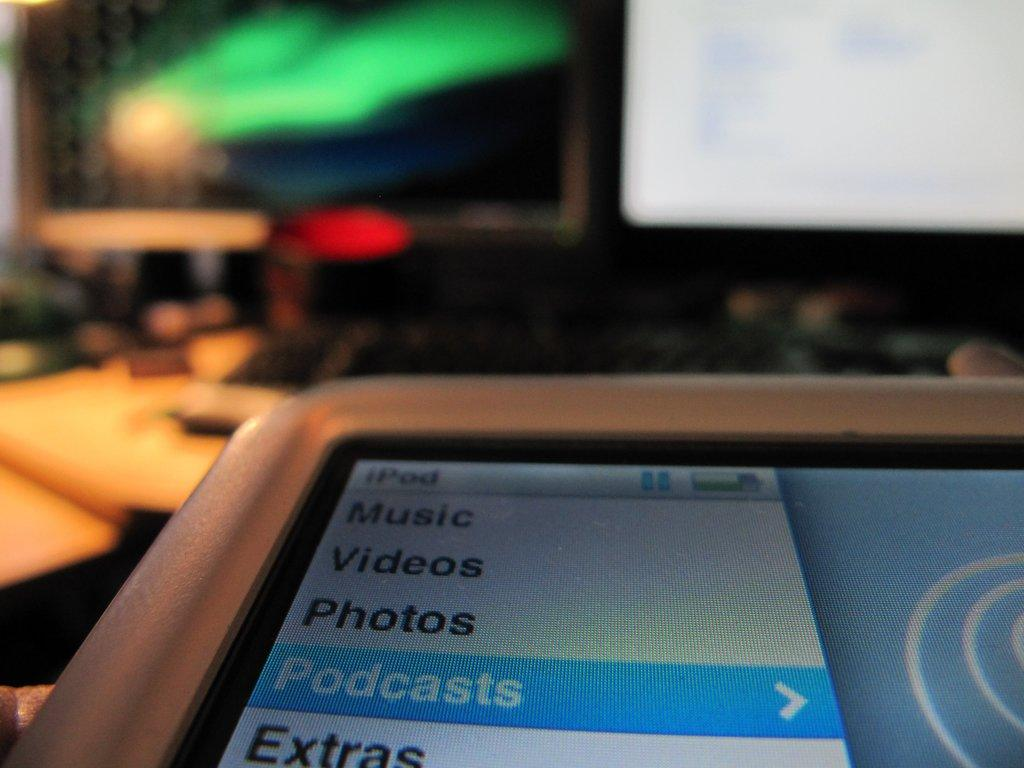Provide a one-sentence caption for the provided image. a device screen is showing music, videos, photos and a few other categories. 